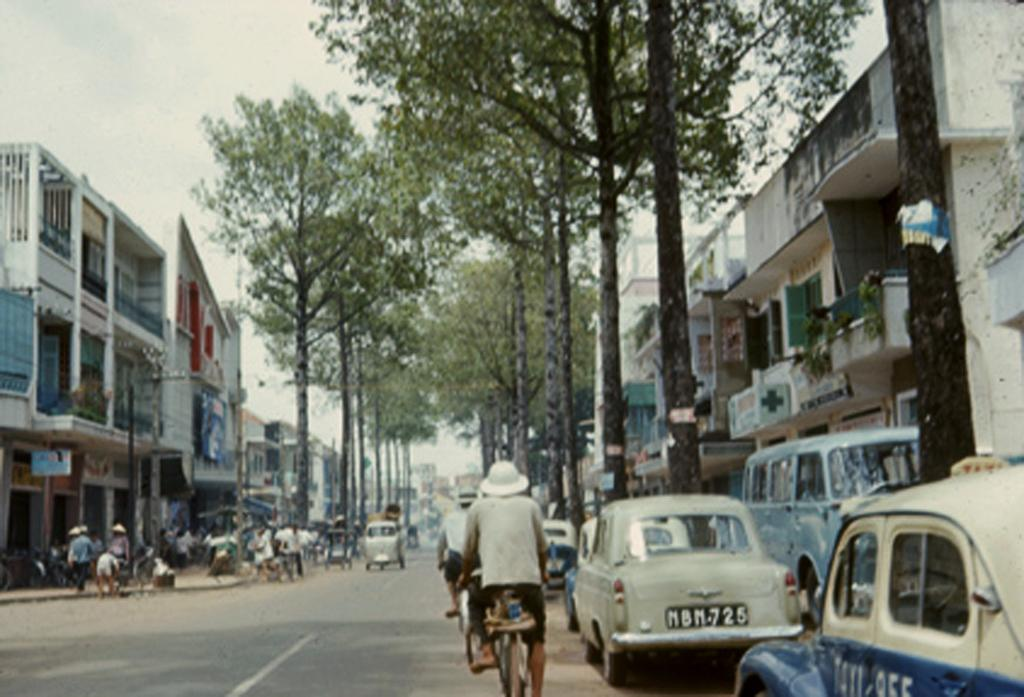How many people are in the image? There is a group of people in the image. What are some of the people doing in the image? Some persons are riding on a bicycle, while others are walking. What can be seen in the background of the image? There are trees, buildings, and the sky visible in the background of the image. What type of button is the judge wearing in the bedroom in the image? There is no judge or bedroom present in the image. The image features a group of people, some of whom are riding a bicycle or walking, with trees, buildings, and the sky visible in the background. 